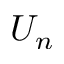<formula> <loc_0><loc_0><loc_500><loc_500>U _ { n }</formula> 